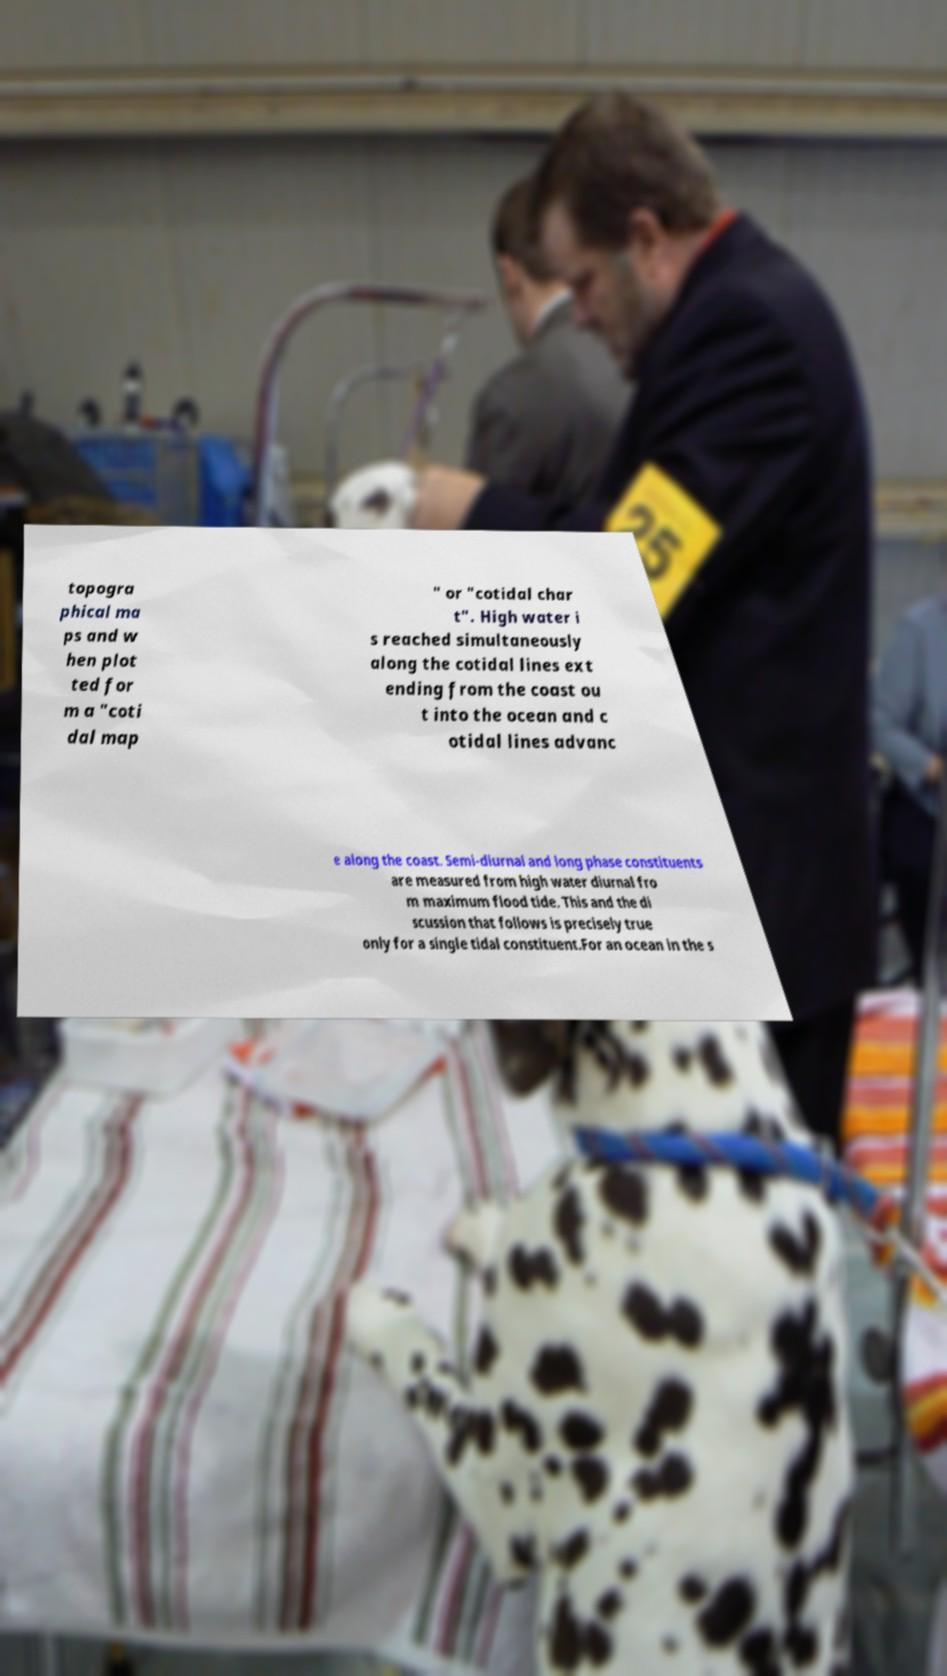Could you assist in decoding the text presented in this image and type it out clearly? topogra phical ma ps and w hen plot ted for m a "coti dal map " or "cotidal char t". High water i s reached simultaneously along the cotidal lines ext ending from the coast ou t into the ocean and c otidal lines advanc e along the coast. Semi-diurnal and long phase constituents are measured from high water diurnal fro m maximum flood tide. This and the di scussion that follows is precisely true only for a single tidal constituent.For an ocean in the s 